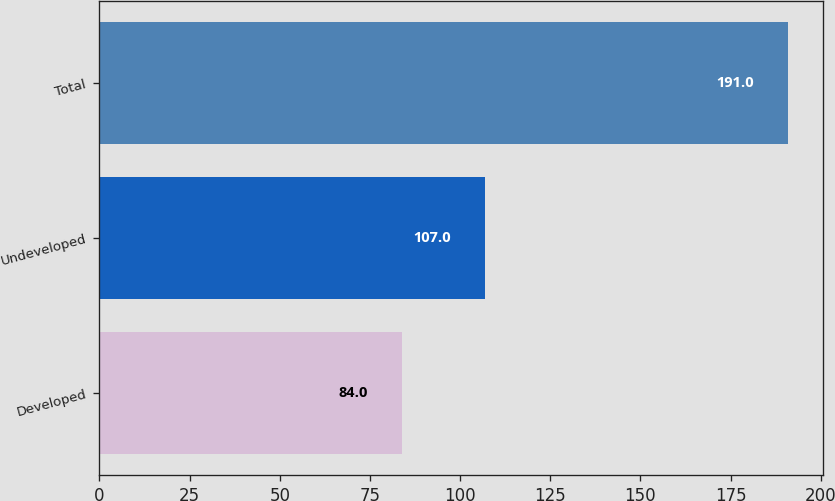<chart> <loc_0><loc_0><loc_500><loc_500><bar_chart><fcel>Developed<fcel>Undeveloped<fcel>Total<nl><fcel>84<fcel>107<fcel>191<nl></chart> 